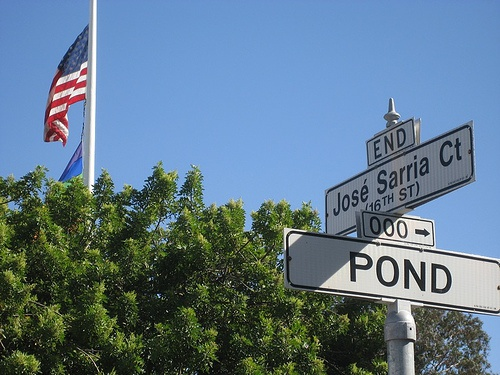Describe the objects in this image and their specific colors. I can see various objects in this image with different colors. 